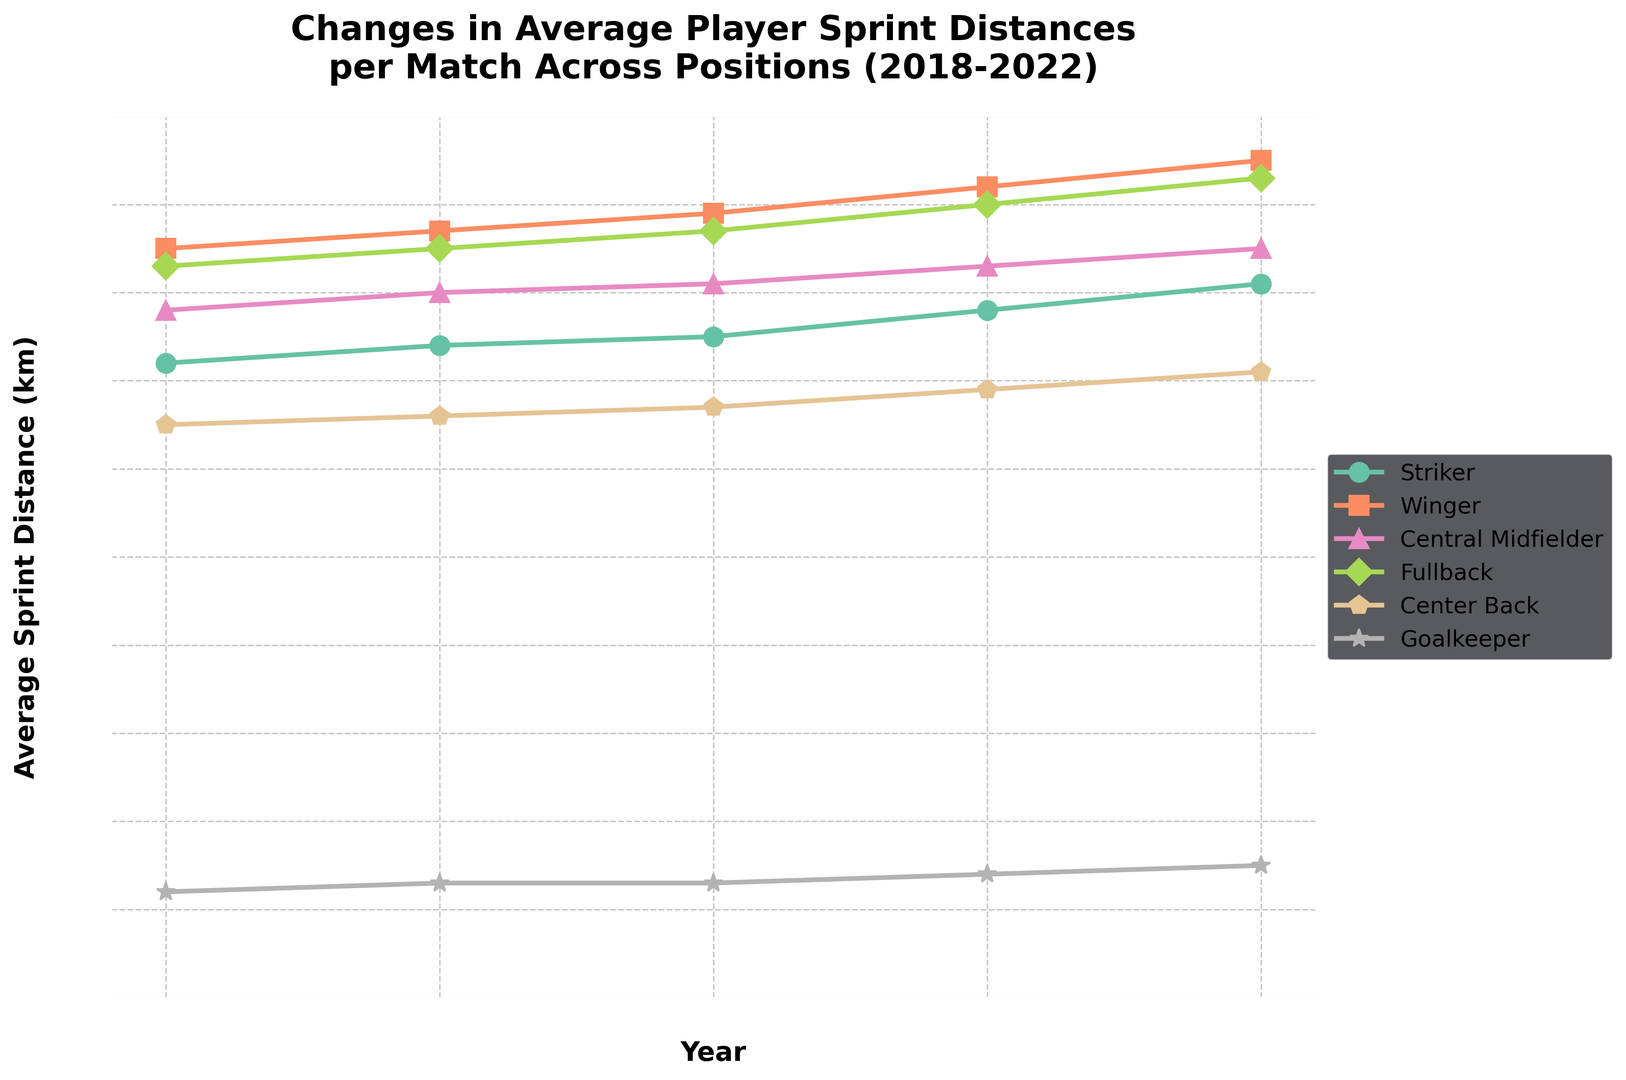What position had the greatest increase in average sprint distance from 2018 to 2022? First, calculate the change in average sprint distance over the years 2018 to 2022 for each position. The changes are: Striker (8.1 - 7.2 = 0.9 km), Winger (9.5 - 8.5 = 1.0 km), Central Midfielder (8.5 - 7.8 = 0.7 km), Fullback (9.3 - 8.3 = 1.0 km), Center Back (7.1 - 6.5 = 0.6 km), Goalkeeper (1.5 - 1.2 = 0.3 km). The greatest increase is 1.0 km, shared by both Winger and Fullback.
Answer: Winger and Fullback Which position had the smallest increase in sprint distance between 2018 and 2022? Calculate the change in sprint distance for each position over the 5 years. The changes are: Striker (0.9 km), Winger (1.0 km), Central Midfielder (0.7 km), Fullback (1.0 km), Center Back (0.6 km), Goalkeeper (0.3 km). The smallest increase is 0.3 km by Goalkeeper.
Answer: Goalkeeper Between 2020 and 2022, which position saw the highest rate of increase in sprint distance? Calculate the rate of increase between 2020 and 2022 for each position by dividing the change by 2 years. The rates are: Striker ((8.1 - 7.5) / 2 = 0.3 km/year), Winger ((9.5 - 8.9) / 2 = 0.3 km/year), Central Midfielder ((8.5 - 8.1) / 2 = 0.2 km/year), Fullback ((9.3 - 8.7) / 2 = 0.3 km/year), Center Back ((7.1 - 6.7) / 2 = 0.2 km/year), Goalkeeper ((1.5 - 1.3) / 2 = 0.1 km/year). The highest rate of increase is 0.3 km/year, observed by Striker, Winger, and Fullback.
Answer: Striker, Winger, and Fullback In 2022, which position had the highest average sprint distance and what was it? Look at the average sprint distances for all positions in 2022. The values are: Striker (8.1 km), Winger (9.5 km), Central Midfielder (8.5 km), Fullback (9.3 km), Center Back (7.1 km), Goalkeeper (1.5 km). The highest value is 9.5 km by Winger.
Answer: Winger with 9.5 km Which position showed a consistent increase in sprint distance every year from 2018 to 2022? Check the year-on-year changes for each position. Striker (7.2, 7.4, 7.5, 7.8, 8.1), Winger (8.5, 8.7, 8.9, 9.2, 9.5), Central Midfielder (7.8, 8.0, 8.1, 8.3, 8.5), Fullback (8.3, 8.5, 8.7, 9.0, 9.3), Center Back (6.5, 6.6, 6.7, 6.9, 7.1), Goalkeeper (1.2, 1.3, 1.3, 1.4, 1.5). All positions except Goalkeeper, who had no change between 2019 and 2020, showed consistent increases.
Answer: Striker, Winger, Central Midfielder, Fullback, and Center Back 